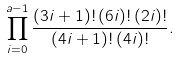<formula> <loc_0><loc_0><loc_500><loc_500>\prod _ { i = 0 } ^ { a - 1 } \frac { ( 3 i + 1 ) ! \, ( 6 i ) ! \, ( 2 i ) ! } { ( 4 i + 1 ) ! \, ( 4 i ) ! } .</formula> 